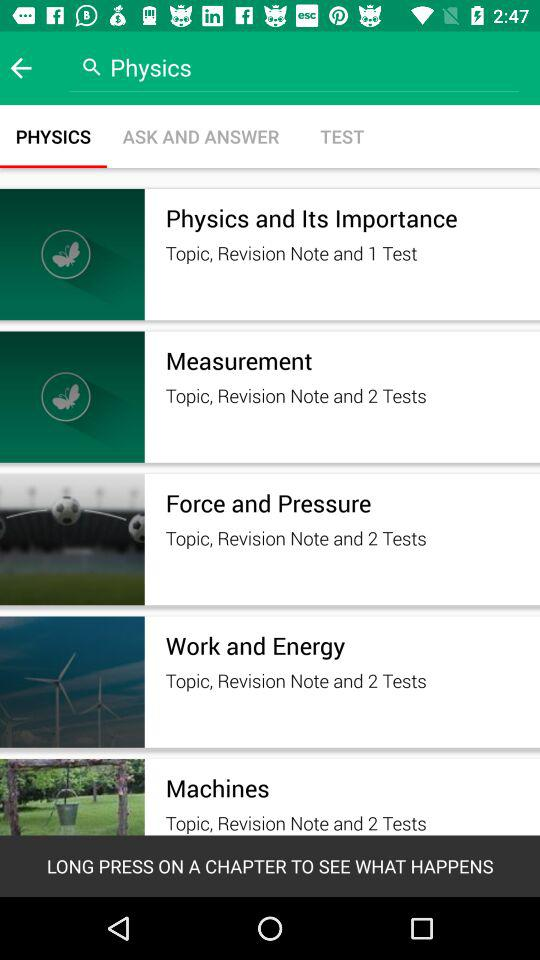How many tests are there for the chapter on Force and Pressure?
Answer the question using a single word or phrase. 2 